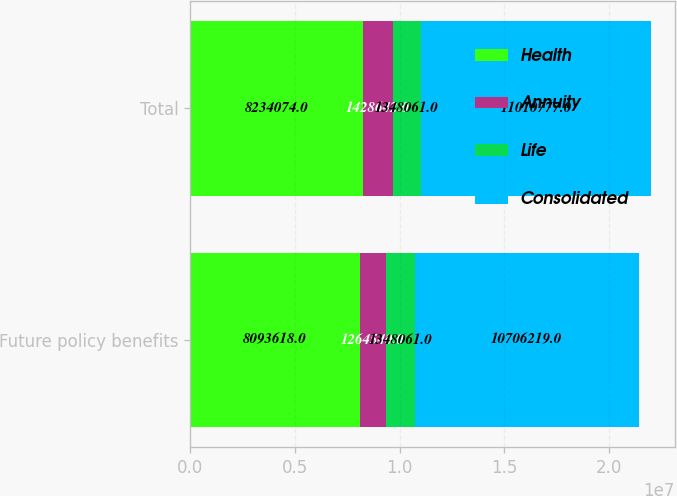Convert chart. <chart><loc_0><loc_0><loc_500><loc_500><stacked_bar_chart><ecel><fcel>Future policy benefits<fcel>Total<nl><fcel>Health<fcel>8.09362e+06<fcel>8.23407e+06<nl><fcel>Annuity<fcel>1.26454e+06<fcel>1.42864e+06<nl><fcel>Life<fcel>1.34806e+06<fcel>1.34806e+06<nl><fcel>Consolidated<fcel>1.07062e+07<fcel>1.10108e+07<nl></chart> 